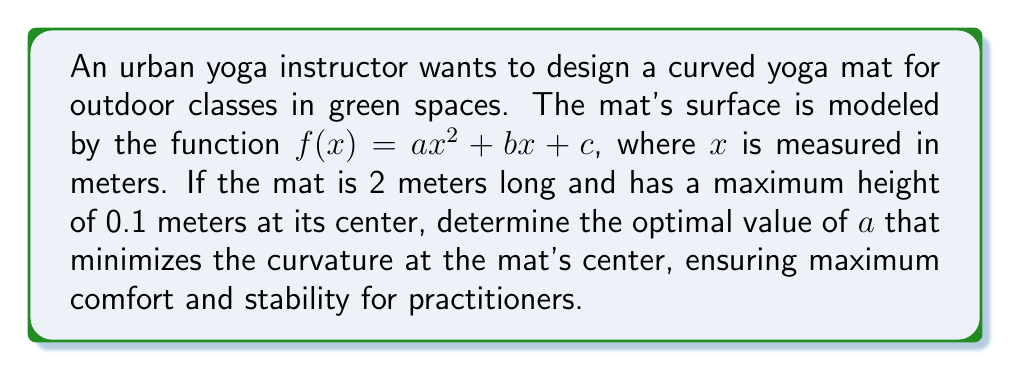Give your solution to this math problem. 1) Given that the mat is 2 meters long, we know that $f(0) = c$ and $f(2) = 4a + 2b + c$ represent the endpoints of the mat.

2) The maximum height occurs at the center (x = 1), so $f(1) = a + b + c = 0.1$

3) Since the mat should be flat at the ends, we can set $f(0) = f(2) = 0$:
   $f(0) = c = 0$
   $f(2) = 4a + 2b + 0 = 0$, so $b = -2a$

4) Substituting these into the equation from step 2:
   $a + (-2a) + 0 = 0.1$
   $-a = 0.1$
   $a = -0.1$

5) The curvature of a function is given by:
   $\kappa = \frac{|f''(x)|}{(1 + (f'(x))^2)^{3/2}}$

6) For $f(x) = ax^2 + bx + c$:
   $f'(x) = 2ax + b$
   $f''(x) = 2a$

7) At the center (x = 1), the curvature is:
   $\kappa = \frac{|2a|}{(1 + (2a + b)^2)^{3/2}}$

8) To minimize curvature, we want to minimize the absolute value of $a$ while satisfying our constraints.

9) The smallest possible value of $|a|$ that satisfies our constraints is $0.1$.

Therefore, the optimal value of $a$ is $-0.1$.
Answer: $a = -0.1$ 